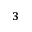Convert formula to latex. <formula><loc_0><loc_0><loc_500><loc_500>^ { 3 }</formula> 